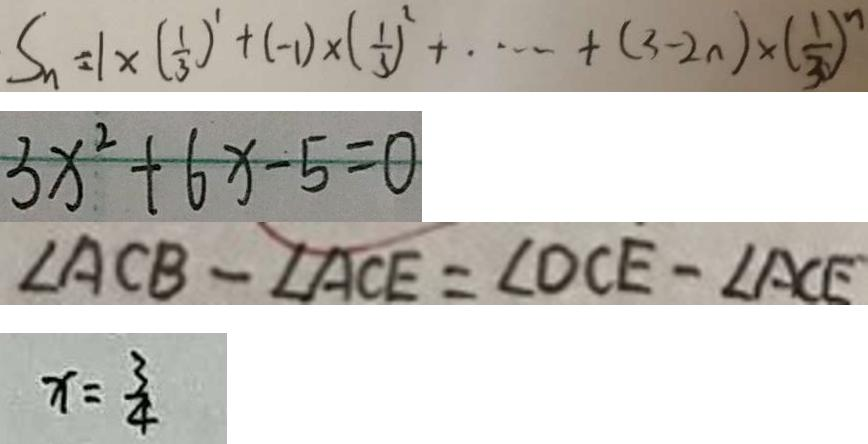<formula> <loc_0><loc_0><loc_500><loc_500>S _ { n } = 1 \times ( \frac { 1 } { 3 } ) ^ { 1 } + ( - 1 ) \times ( \frac { 1 } { 3 } ) ^ { 2 } + \cdots + ( 3 - 2 n ) \times ( \frac { 1 } { 3 } ) ^ { n } 
 3 x ^ { 2 } + 6 x - 5 = 0 
 \angle A C B - \angle A C E = \angle D C E - \angle A C E 
 x = \frac { 3 } { 4 }</formula> 